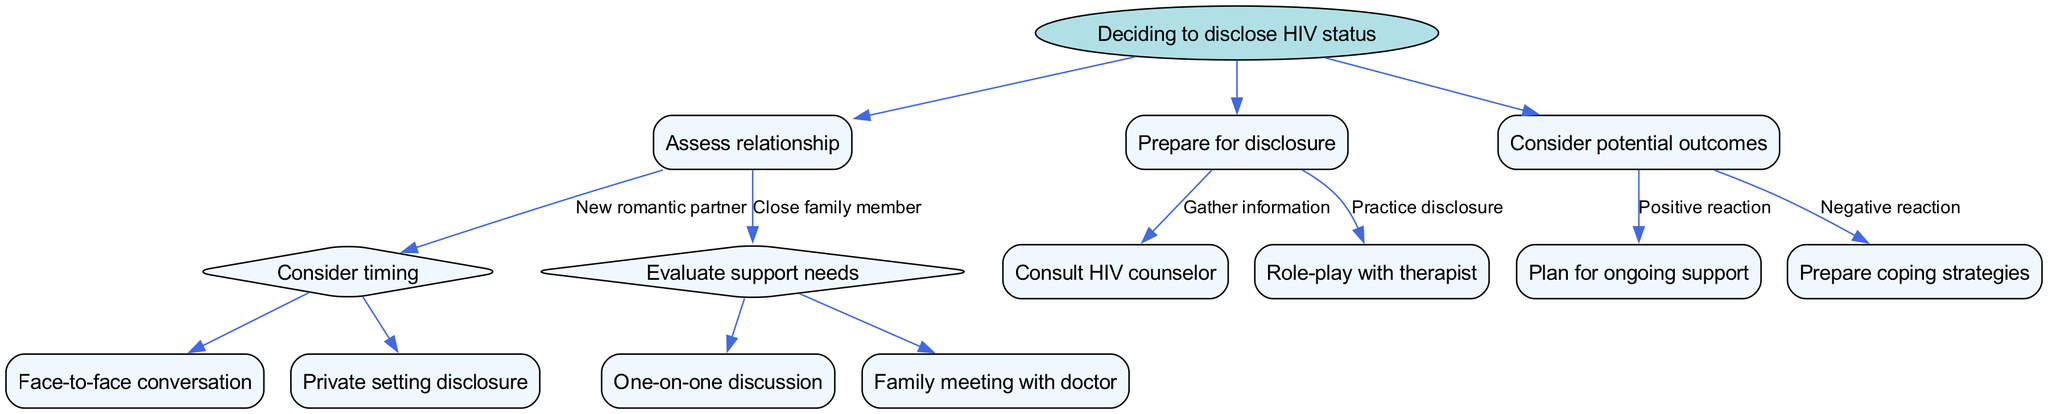What is the root of the decision tree? The root of the decision tree is the main question or topic that the tree explores. In this case, it states, "Deciding to disclose HIV status."
Answer: Deciding to disclose HIV status How many branches are there from the root node? The tree contains three primary branches stemming from the root, which represent different aspects of the decision-making process regarding disclosure.
Answer: 3 What is the node that follows "New romantic partner"? The node that follows "New romantic partner" is a subsequent decision point where you must "Consider timing," indicating the next step in the disclosure process.
Answer: Consider timing What are the two options under "Evaluate support needs"? The two options under this node are "Need emotional support" and "Need practical support," indicating different approaches based on the type of support required from a close family member.
Answer: Need emotional support; Need practical support What type of disclosure is recommended "Before intimacy"? The specified type of disclosure before intimacy is to have a "Face-to-face conversation," emphasizing personal interaction at a critical stage in the relationship.
Answer: Face-to-face conversation If the reaction is negative, what should one prepare for? If the reaction to the disclosure is negative, it is advised to "Prepare coping strategies," allowing individuals to manage their emotional and psychological responses effectively.
Answer: Prepare coping strategies What is the action suggested for "Gather information"? The action suggested for "Gather information" is to "Consult HIV counselor," which indicates seeking professional guidance before disclosing one's status.
Answer: Consult HIV counselor Under what conditions is a "Family meeting with doctor" suggested? A "Family meeting with doctor" is suggested if there is a "Need practical support," involving the whole family in understanding the health implications and necessary actions.
Answer: Need practical support What do you plan for if the reaction is positive? If the reaction is positive, the tree suggests to "Plan for ongoing support," which implies the importance of establishing continued emotional or practical assistance post-disclosure.
Answer: Plan for ongoing support 